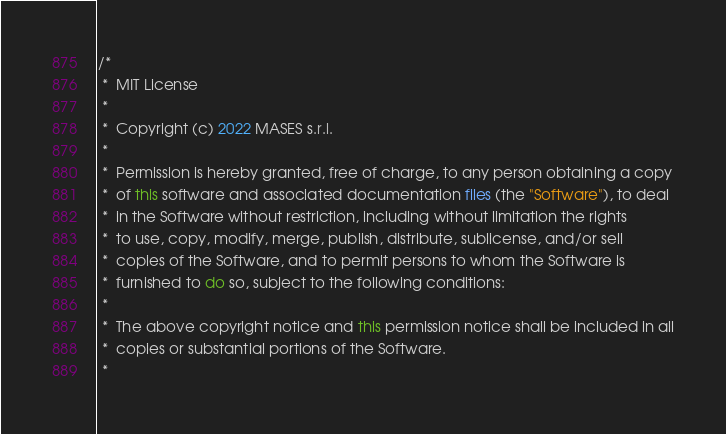Convert code to text. <code><loc_0><loc_0><loc_500><loc_500><_Java_>/*
 *  MIT License
 *
 *  Copyright (c) 2022 MASES s.r.l.
 *
 *  Permission is hereby granted, free of charge, to any person obtaining a copy
 *  of this software and associated documentation files (the "Software"), to deal
 *  in the Software without restriction, including without limitation the rights
 *  to use, copy, modify, merge, publish, distribute, sublicense, and/or sell
 *  copies of the Software, and to permit persons to whom the Software is
 *  furnished to do so, subject to the following conditions:
 *
 *  The above copyright notice and this permission notice shall be included in all
 *  copies or substantial portions of the Software.
 *</code> 